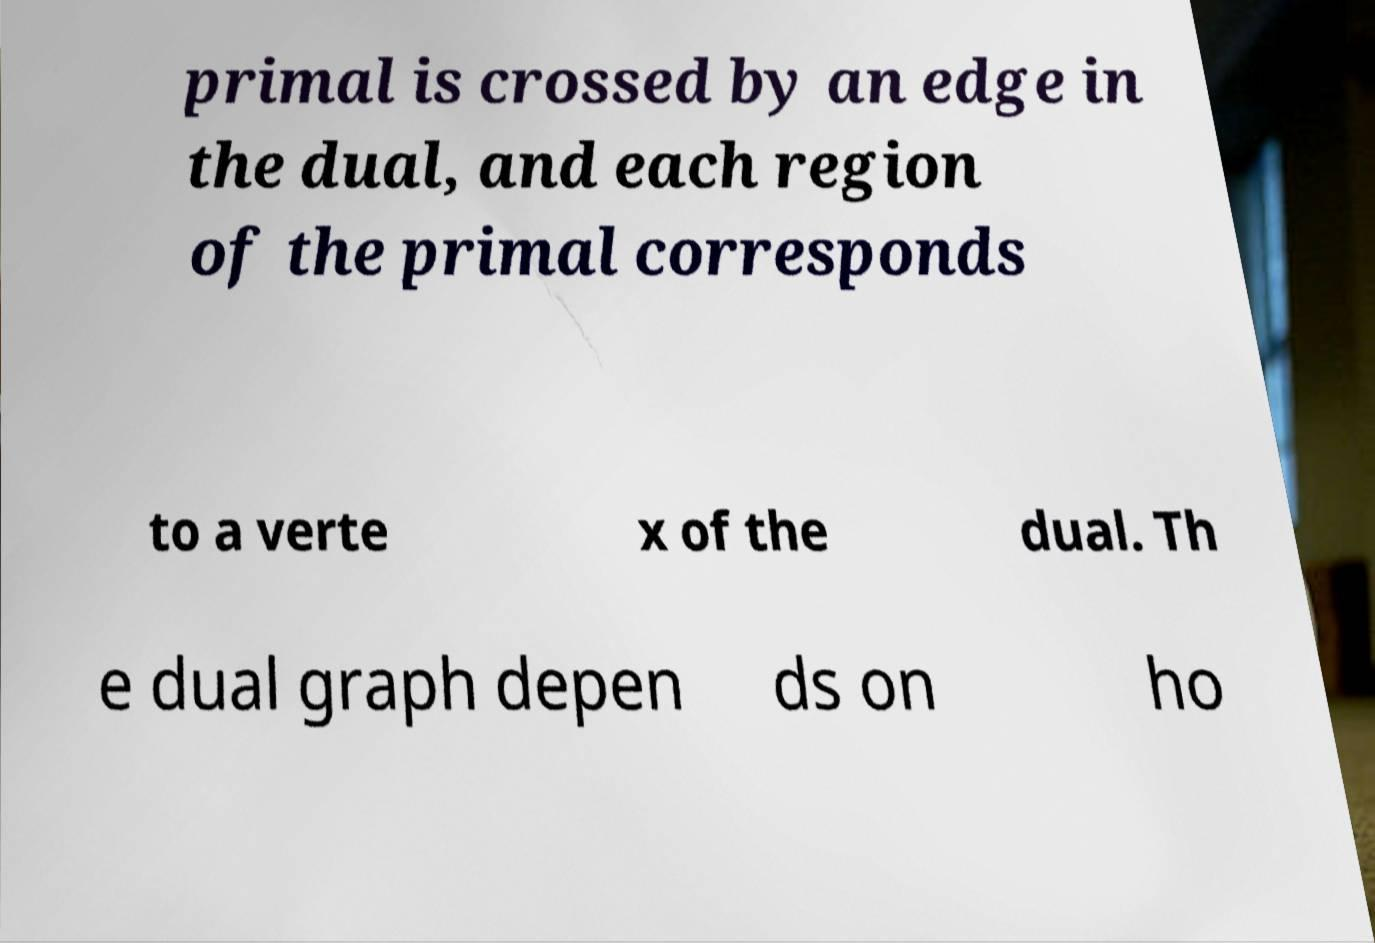There's text embedded in this image that I need extracted. Can you transcribe it verbatim? primal is crossed by an edge in the dual, and each region of the primal corresponds to a verte x of the dual. Th e dual graph depen ds on ho 